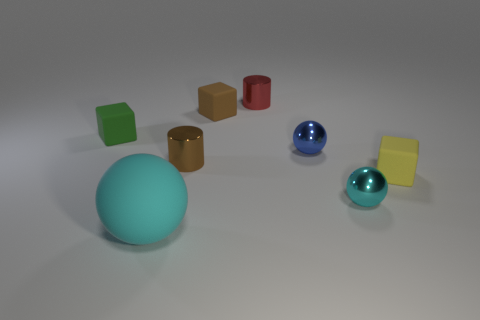Add 2 red cylinders. How many objects exist? 10 Subtract all spheres. How many objects are left? 5 Add 7 small cubes. How many small cubes are left? 10 Add 5 small brown metallic objects. How many small brown metallic objects exist? 6 Subtract 1 blue balls. How many objects are left? 7 Subtract all green matte things. Subtract all blue spheres. How many objects are left? 6 